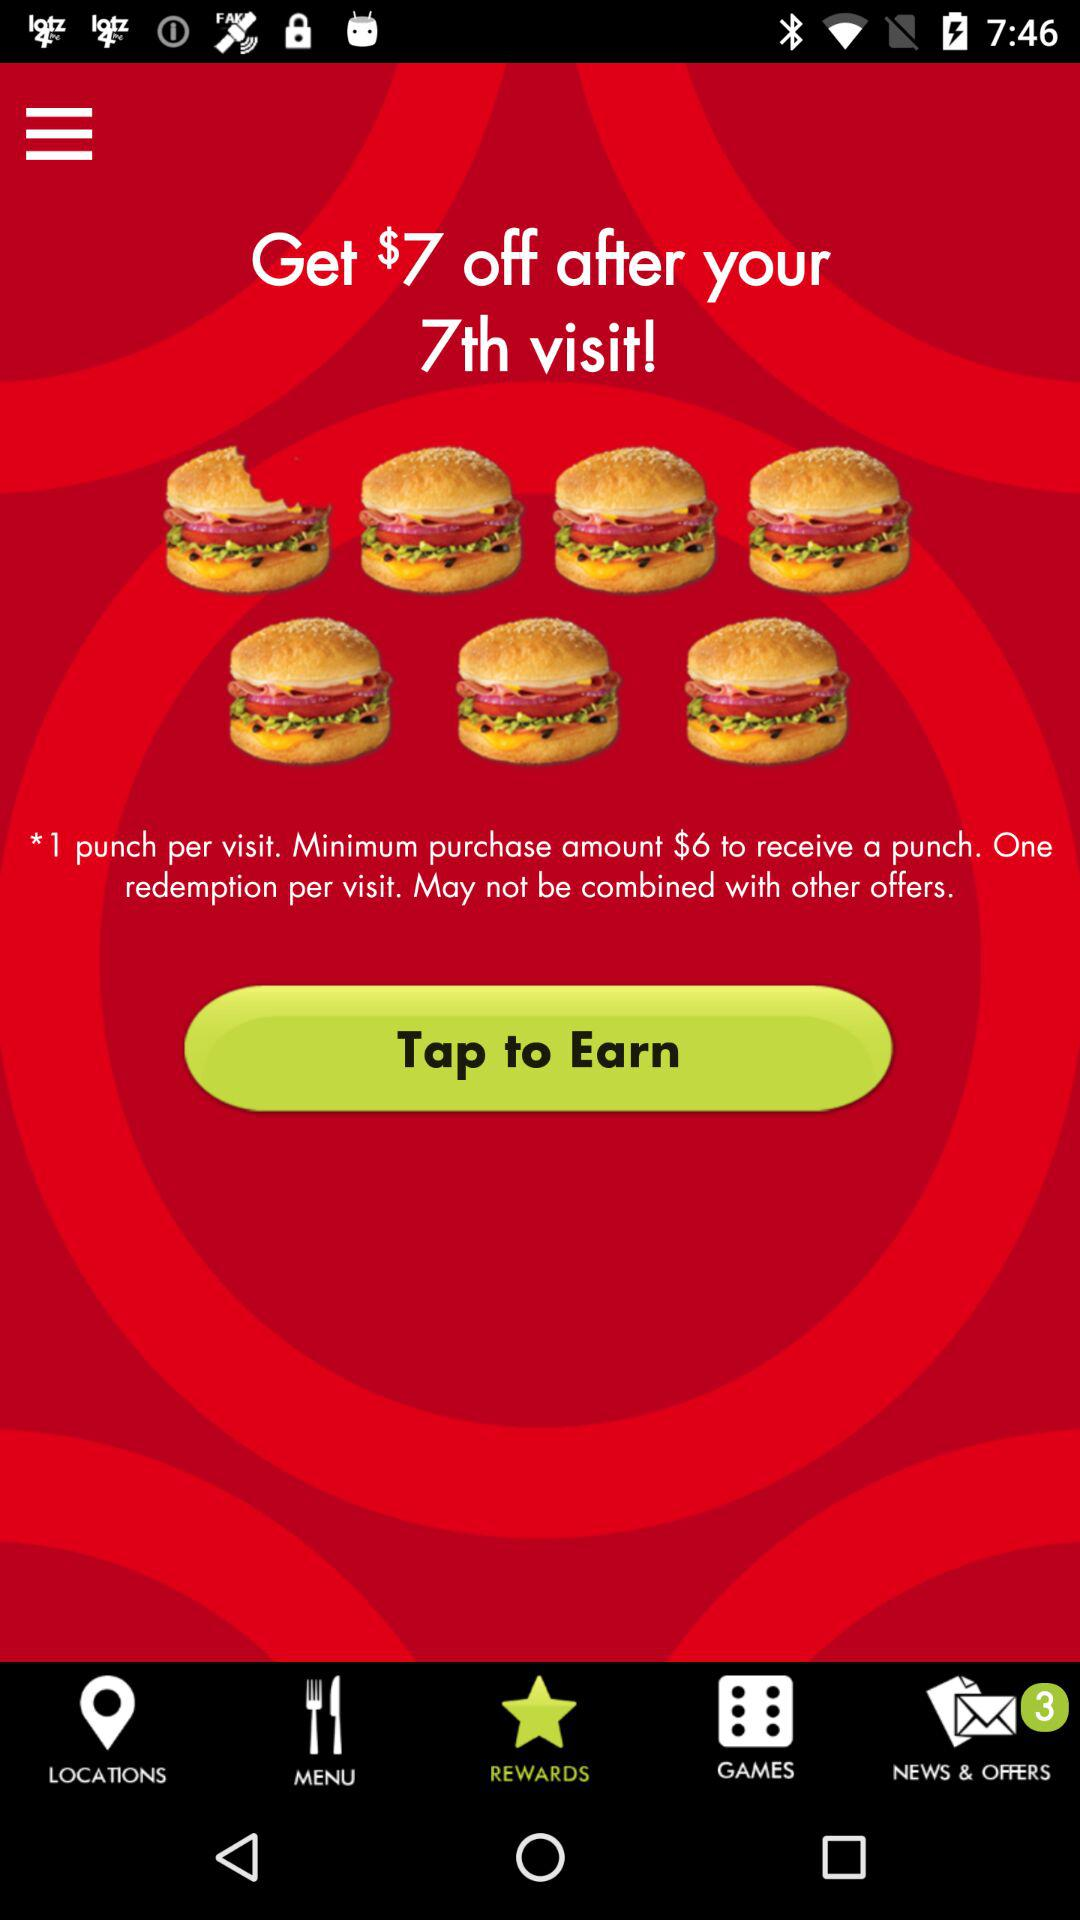How many punches do you need to get $7 off?
Answer the question using a single word or phrase. 7 